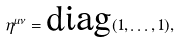<formula> <loc_0><loc_0><loc_500><loc_500>\eta ^ { \mu \nu } = \text {diag} ( 1 , \dots , 1 ) ,</formula> 